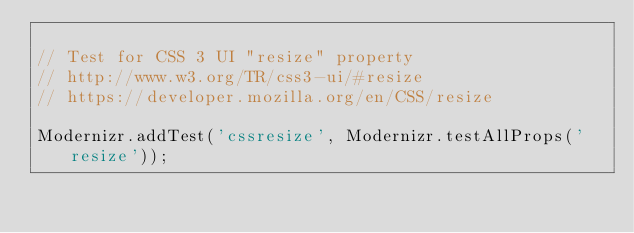<code> <loc_0><loc_0><loc_500><loc_500><_JavaScript_>
// Test for CSS 3 UI "resize" property
// http://www.w3.org/TR/css3-ui/#resize
// https://developer.mozilla.org/en/CSS/resize

Modernizr.addTest('cssresize', Modernizr.testAllProps('resize'));


</code> 